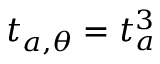Convert formula to latex. <formula><loc_0><loc_0><loc_500><loc_500>t _ { a , \theta } = t _ { a } ^ { 3 }</formula> 